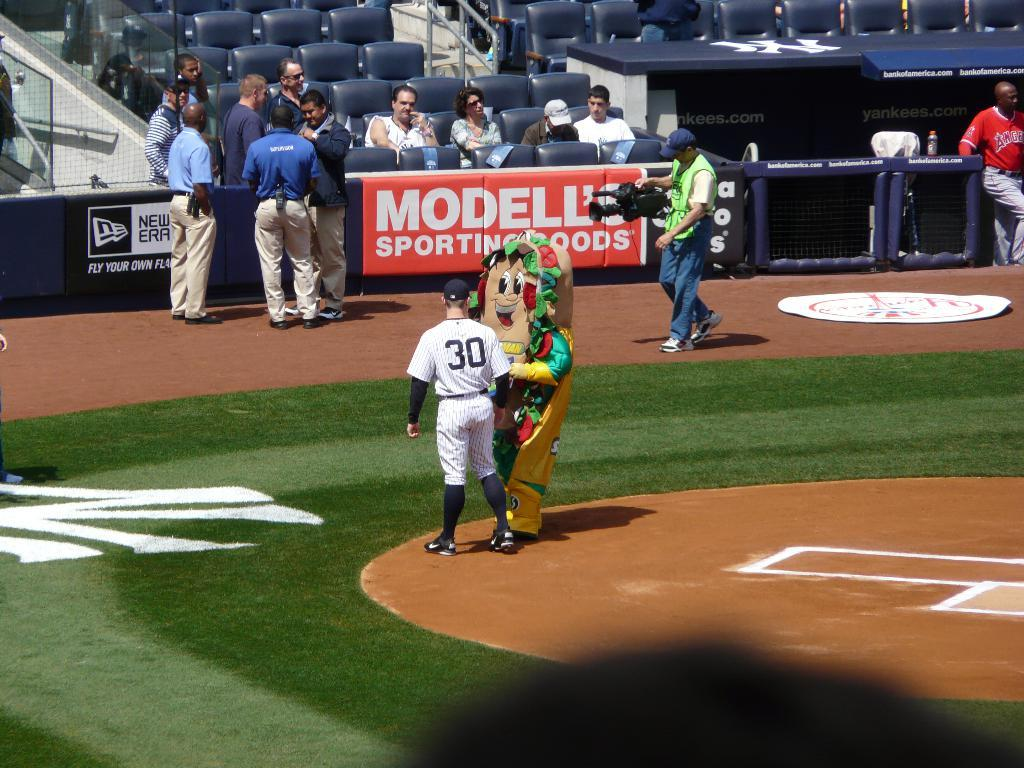<image>
Offer a succinct explanation of the picture presented. A baseball field with an ad for Modell's sporting goods. 